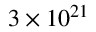<formula> <loc_0><loc_0><loc_500><loc_500>3 \times 1 0 ^ { 2 1 }</formula> 